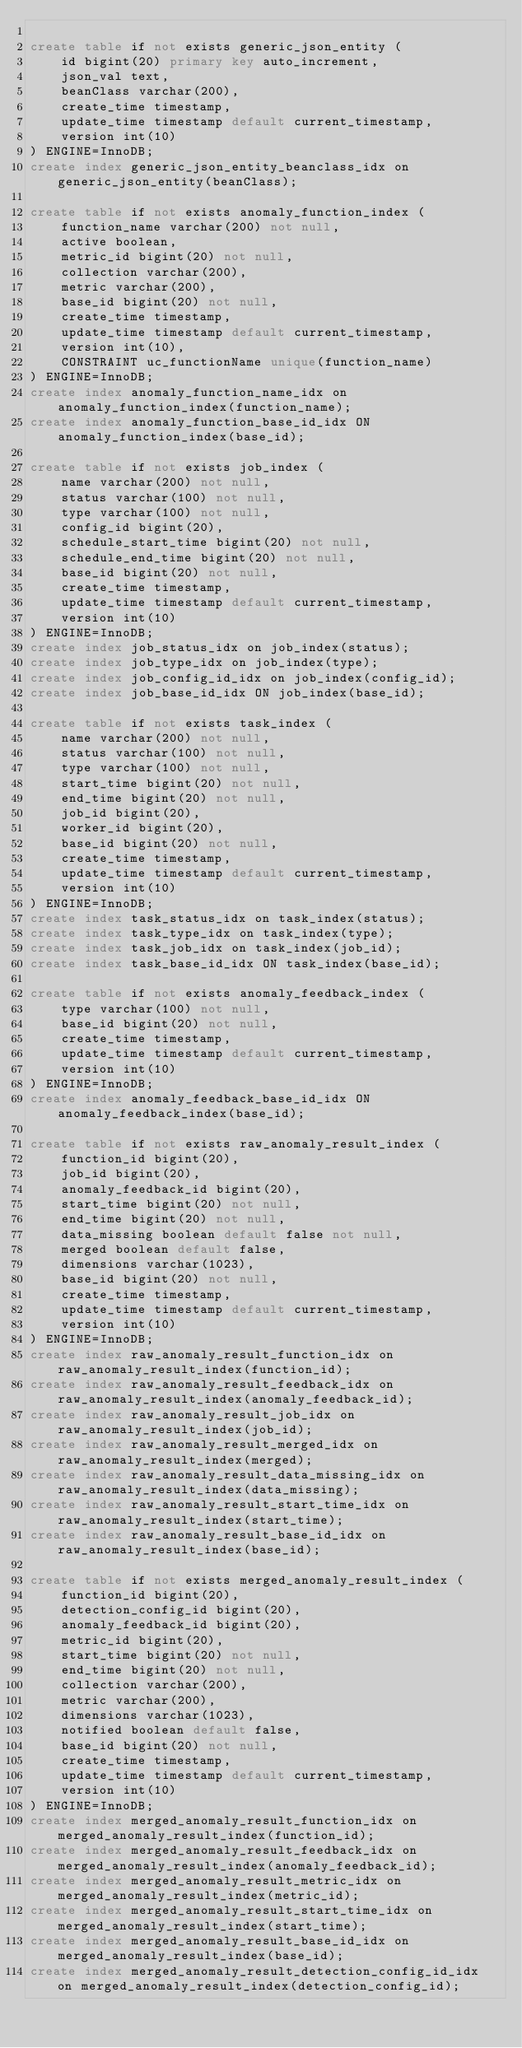Convert code to text. <code><loc_0><loc_0><loc_500><loc_500><_SQL_>
create table if not exists generic_json_entity (
    id bigint(20) primary key auto_increment,
    json_val text,
    beanClass varchar(200),
    create_time timestamp,
    update_time timestamp default current_timestamp,
    version int(10)
) ENGINE=InnoDB;
create index generic_json_entity_beanclass_idx on generic_json_entity(beanClass);

create table if not exists anomaly_function_index (
    function_name varchar(200) not null,
    active boolean,
    metric_id bigint(20) not null,
    collection varchar(200),
    metric varchar(200),
    base_id bigint(20) not null,
    create_time timestamp,
    update_time timestamp default current_timestamp,
    version int(10),
    CONSTRAINT uc_functionName unique(function_name)
) ENGINE=InnoDB;
create index anomaly_function_name_idx on anomaly_function_index(function_name);
create index anomaly_function_base_id_idx ON anomaly_function_index(base_id);

create table if not exists job_index (
    name varchar(200) not null,
    status varchar(100) not null,
    type varchar(100) not null,
    config_id bigint(20),
    schedule_start_time bigint(20) not null,
    schedule_end_time bigint(20) not null,
    base_id bigint(20) not null,
    create_time timestamp,
    update_time timestamp default current_timestamp,
    version int(10)
) ENGINE=InnoDB;
create index job_status_idx on job_index(status);
create index job_type_idx on job_index(type);
create index job_config_id_idx on job_index(config_id);
create index job_base_id_idx ON job_index(base_id);

create table if not exists task_index (
    name varchar(200) not null,
    status varchar(100) not null,
    type varchar(100) not null,
    start_time bigint(20) not null,
    end_time bigint(20) not null,
    job_id bigint(20),
    worker_id bigint(20),
    base_id bigint(20) not null,
    create_time timestamp,
    update_time timestamp default current_timestamp,
    version int(10)
) ENGINE=InnoDB;
create index task_status_idx on task_index(status);
create index task_type_idx on task_index(type);
create index task_job_idx on task_index(job_id);
create index task_base_id_idx ON task_index(base_id);

create table if not exists anomaly_feedback_index (
    type varchar(100) not null,
    base_id bigint(20) not null,
    create_time timestamp,
    update_time timestamp default current_timestamp,
    version int(10)
) ENGINE=InnoDB;
create index anomaly_feedback_base_id_idx ON anomaly_feedback_index(base_id);

create table if not exists raw_anomaly_result_index (
    function_id bigint(20),
    job_id bigint(20),
    anomaly_feedback_id bigint(20),
    start_time bigint(20) not null,
    end_time bigint(20) not null,
    data_missing boolean default false not null,
    merged boolean default false,
    dimensions varchar(1023),
    base_id bigint(20) not null,
    create_time timestamp,
    update_time timestamp default current_timestamp,
    version int(10)
) ENGINE=InnoDB;
create index raw_anomaly_result_function_idx on raw_anomaly_result_index(function_id);
create index raw_anomaly_result_feedback_idx on raw_anomaly_result_index(anomaly_feedback_id);
create index raw_anomaly_result_job_idx on raw_anomaly_result_index(job_id);
create index raw_anomaly_result_merged_idx on raw_anomaly_result_index(merged);
create index raw_anomaly_result_data_missing_idx on raw_anomaly_result_index(data_missing);
create index raw_anomaly_result_start_time_idx on raw_anomaly_result_index(start_time);
create index raw_anomaly_result_base_id_idx on raw_anomaly_result_index(base_id);

create table if not exists merged_anomaly_result_index (
    function_id bigint(20),
    detection_config_id bigint(20),
    anomaly_feedback_id bigint(20),
    metric_id bigint(20),
    start_time bigint(20) not null,
    end_time bigint(20) not null,
    collection varchar(200),
    metric varchar(200),
    dimensions varchar(1023),
    notified boolean default false,
    base_id bigint(20) not null,
    create_time timestamp,
    update_time timestamp default current_timestamp,
    version int(10)
) ENGINE=InnoDB;
create index merged_anomaly_result_function_idx on merged_anomaly_result_index(function_id);
create index merged_anomaly_result_feedback_idx on merged_anomaly_result_index(anomaly_feedback_id);
create index merged_anomaly_result_metric_idx on merged_anomaly_result_index(metric_id);
create index merged_anomaly_result_start_time_idx on merged_anomaly_result_index(start_time);
create index merged_anomaly_result_base_id_idx on merged_anomaly_result_index(base_id);
create index merged_anomaly_result_detection_config_id_idx on merged_anomaly_result_index(detection_config_id);
</code> 